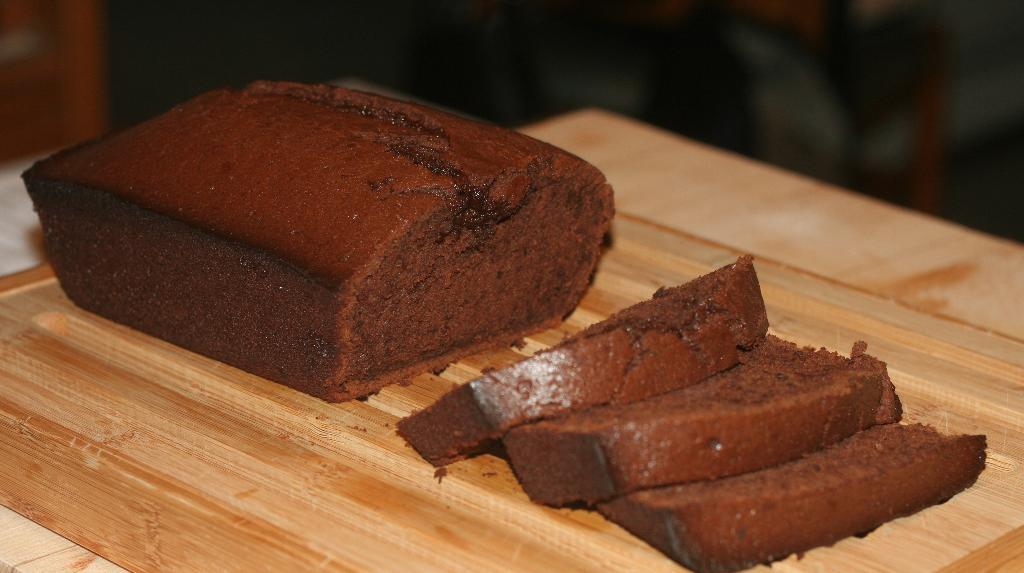What is placed on the wooden plank in the image? There are cake pieces on a wooden plank in the image. Can you describe the wooden plank in the image? The wooden plank is the surface on which the cake pieces are placed. What type of crown is worn by the cake pieces in the image? There is no crown present in the image; it features cake pieces on a wooden plank. 